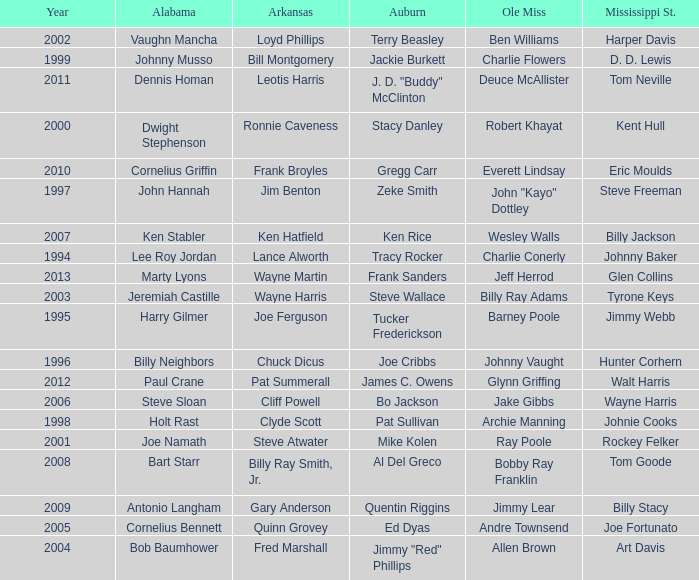Who was the Ole Miss player associated with Chuck Dicus? Johnny Vaught. 